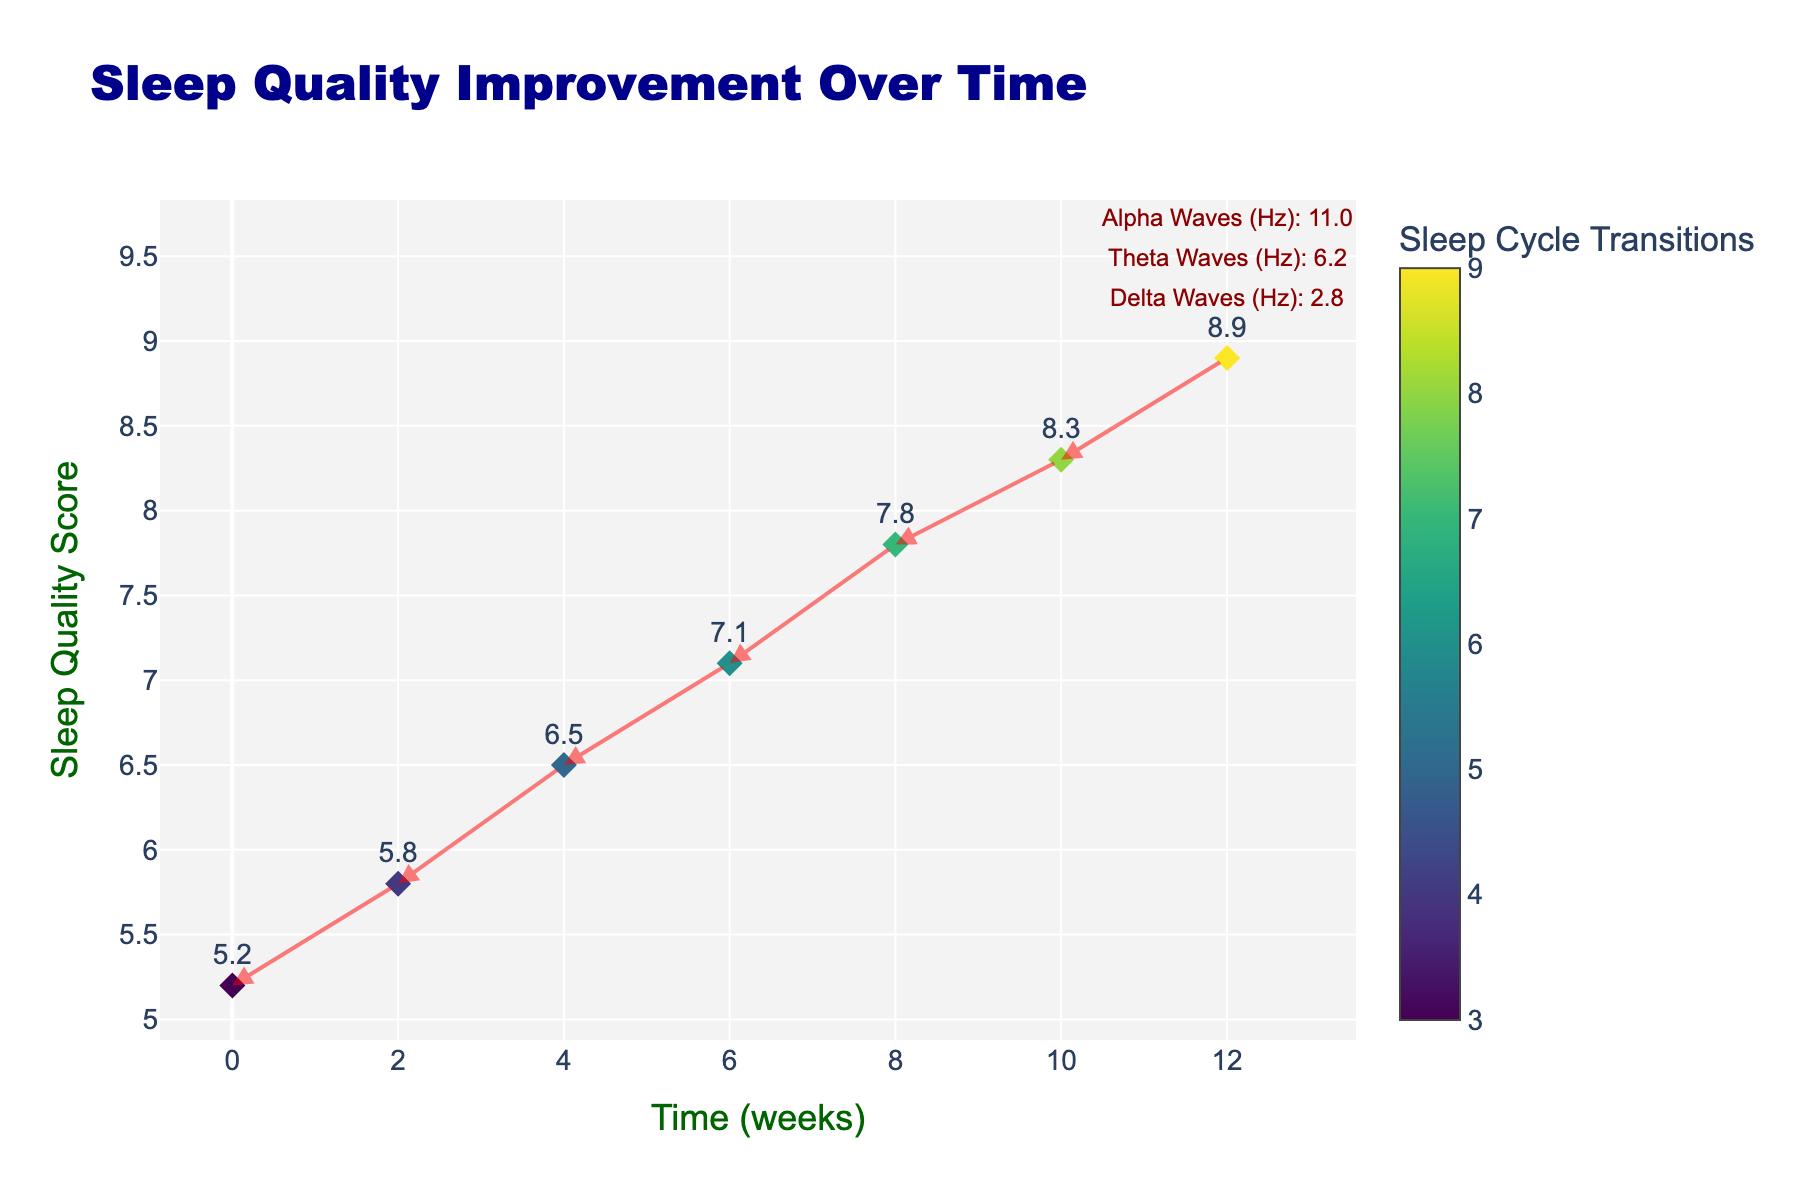When does the sleep quality score reach its highest value? The highest value for sleep quality is shown at the last time point on the x-axis (Time in weeks). The corresponding y-axis value gives us the sleep quality score. This occurs at 12 weeks.
Answer: 12 weeks How many sleep cycle transitions are there at 6 weeks? Locate the data point corresponding to 6 weeks on the x-axis and refer to the color scale or the numerical marker associated with that point to find the number of sleep cycle transitions.
Answer: 6 What is the change in sleep quality score between weeks 2 and 4? Locate the sleep quality scores at week 2 and week 4 on the y-axis. Subtract the score at week 2 from the score at week 4 to find the change. (6.5 - 5.8).
Answer: 0.7 Are sleep quality scores generally increasing or decreasing over time? Observe the direction and placement of the arrows connecting the data points. If the arrows generally point upwards, it indicates an increase over time.
Answer: Increasing Which brain wave patterns are annotated at the last data point? Look at the text annotations at the last data point, which provide information about the different brain wave patterns.
Answer: Delta Waves, Theta Waves, Alpha Waves How many data points are plotted on the figure? Count the number of markers on the plot that represent each time point.
Answer: 7 Which week shows the least improvement in sleep quality compared to the previous point? Assess each arrow's direction and length. The smallest vertical change between two consecutive points will indicate the least improvement.
Answer: Between 6 and 8 weeks Do the number of sleep cycle transitions increase consistently over time? Check the color scale and the markers representing the number of sleep cycle transitions at each time point. Observing the trend can confirm if it's consistent.
Answer: Yes What is the sleep quality score at 8 weeks? Locate the data point at 8 weeks on the x-axis and find its corresponding y-axis value.
Answer: 7.8 Is there a correlation between the number of sleep cycle transitions and sleep quality scores based on the figure? By observing the trend in marker colors and their corresponding sleep quality scores over the weeks, one can infer a correlation. As the number of transitions increases (darker colors), the sleep quality score tends to increase.
Answer: Yes 